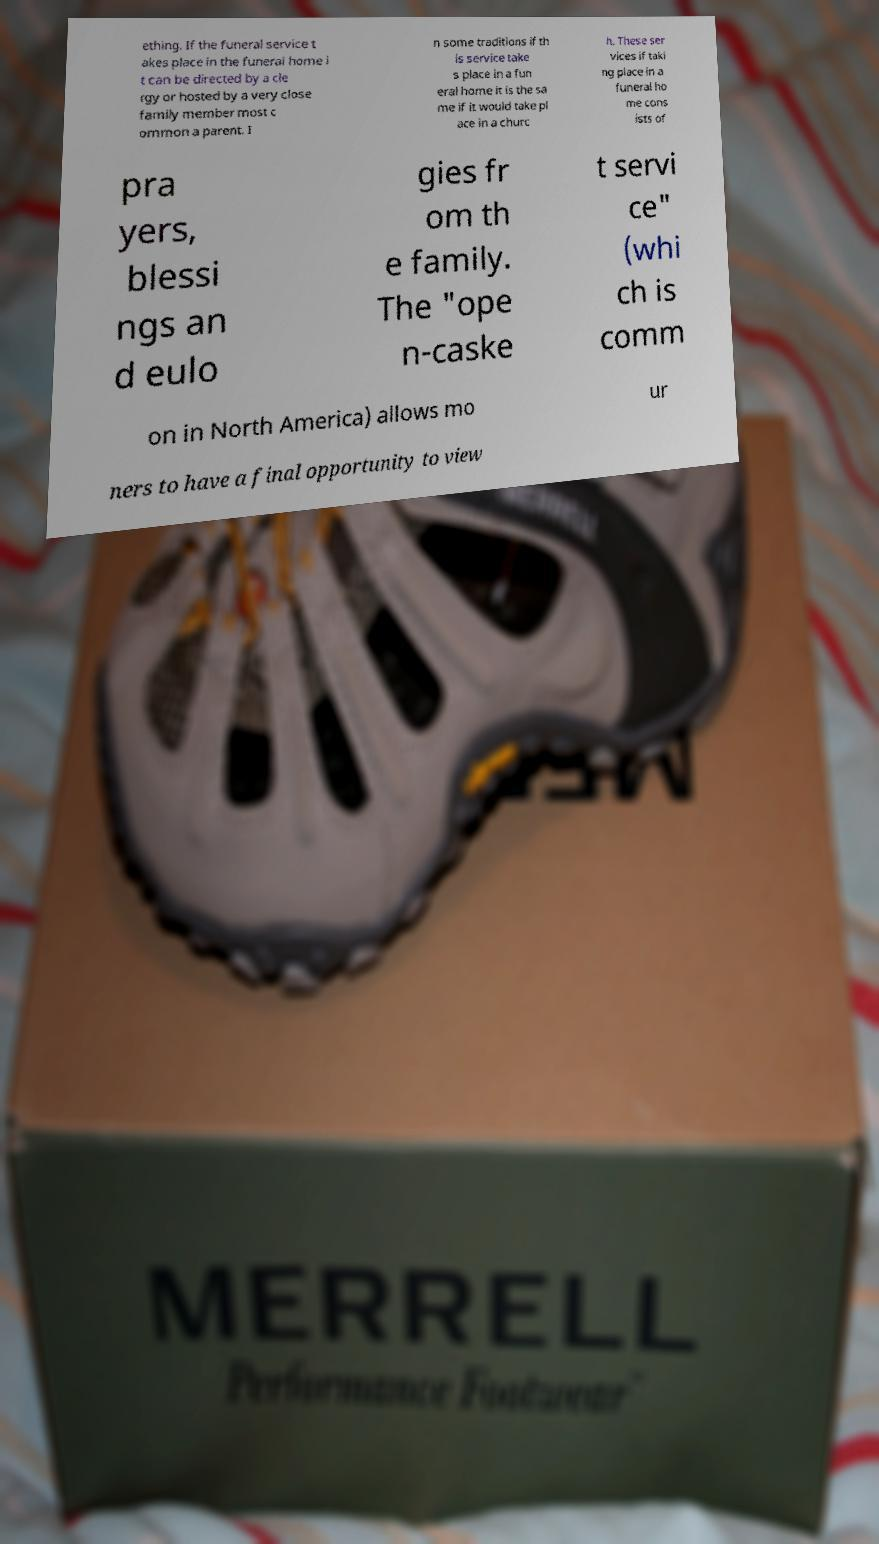Could you assist in decoding the text presented in this image and type it out clearly? ething. If the funeral service t akes place in the funeral home i t can be directed by a cle rgy or hosted by a very close family member most c ommon a parent. I n some traditions if th is service take s place in a fun eral home it is the sa me if it would take pl ace in a churc h. These ser vices if taki ng place in a funeral ho me cons ists of pra yers, blessi ngs an d eulo gies fr om th e family. The "ope n-caske t servi ce" (whi ch is comm on in North America) allows mo ur ners to have a final opportunity to view 